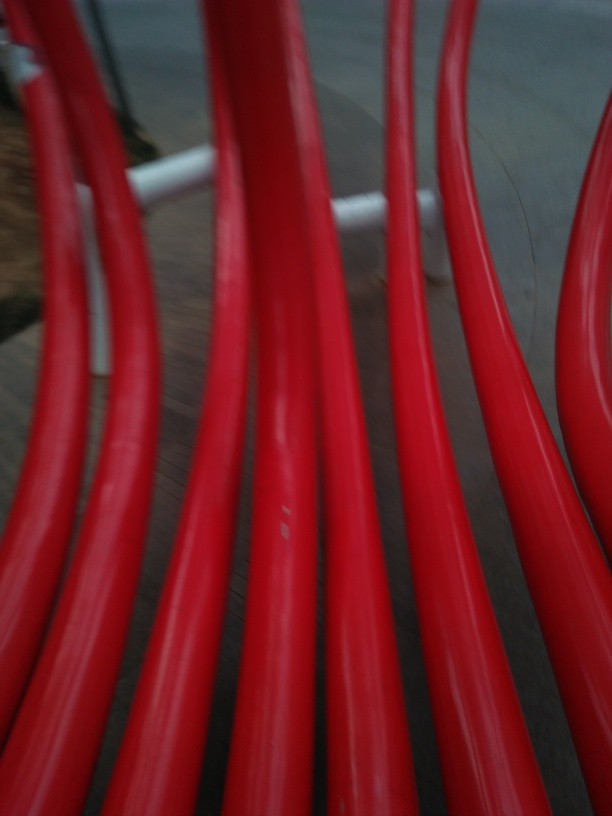What are some issues with the focusing? Based on the examination of the image, it appears that there are indeed some focusing issues. The photo is blurry, which suggests that the camera's focus was not properly set when the picture was taken. This could be due to a quick movement either of the subject or the camera at the time of capture, or a misalignment of the autofocus feature if used. 